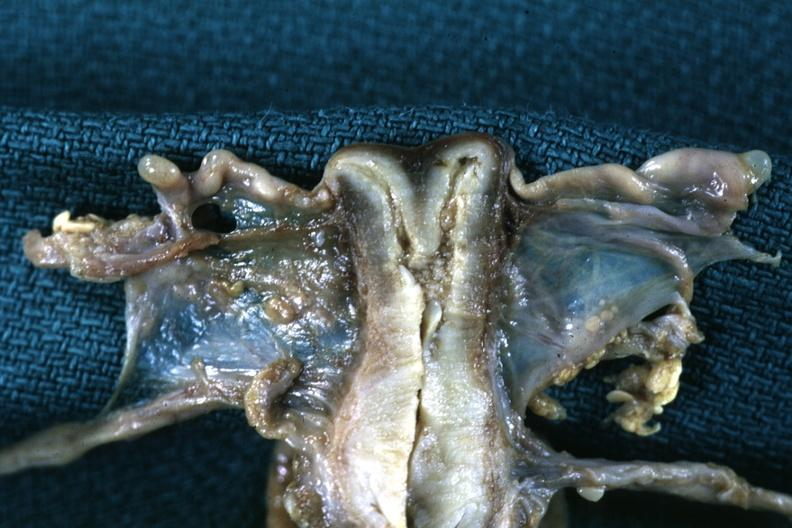what does this image show?
Answer the question using a single word or phrase. Fixed tissue frontal section single fundus duplicated endocervix and exocervix 